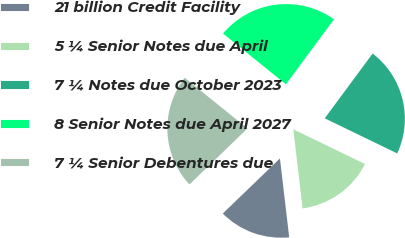Convert chart. <chart><loc_0><loc_0><loc_500><loc_500><pie_chart><fcel>21 billion Credit Facility<fcel>5 ¼ Senior Notes due April<fcel>7 ¼ Notes due October 2023<fcel>8 Senior Notes due April 2027<fcel>7 ¼ Senior Debentures due<nl><fcel>14.65%<fcel>15.96%<fcel>22.04%<fcel>24.32%<fcel>23.02%<nl></chart> 